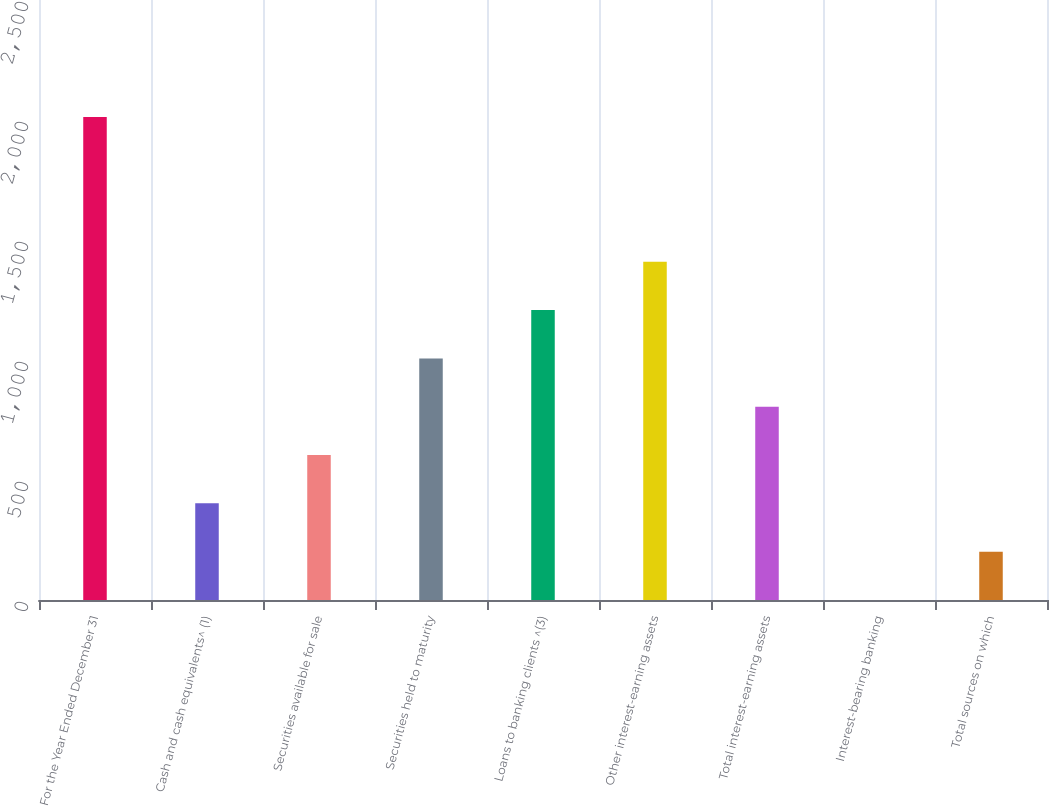<chart> <loc_0><loc_0><loc_500><loc_500><bar_chart><fcel>For the Year Ended December 31<fcel>Cash and cash equivalents^ (1)<fcel>Securities available for sale<fcel>Securities held to maturity<fcel>Loans to banking clients ^(3)<fcel>Other interest-earning assets<fcel>Total interest-earning assets<fcel>Interest-bearing banking<fcel>Total sources on which<nl><fcel>2013<fcel>402.64<fcel>603.94<fcel>1006.54<fcel>1207.84<fcel>1409.14<fcel>805.24<fcel>0.04<fcel>201.34<nl></chart> 